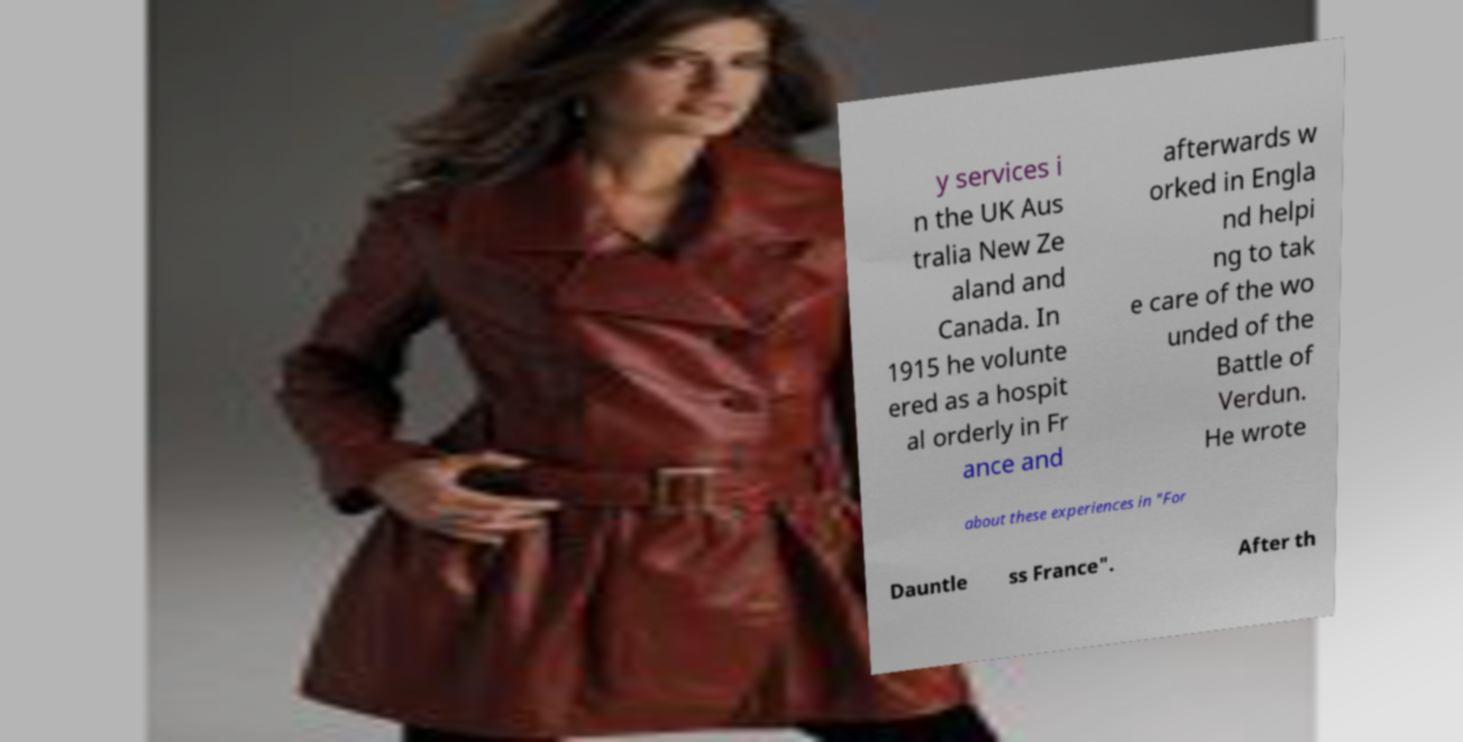Can you read and provide the text displayed in the image?This photo seems to have some interesting text. Can you extract and type it out for me? y services i n the UK Aus tralia New Ze aland and Canada. In 1915 he volunte ered as a hospit al orderly in Fr ance and afterwards w orked in Engla nd helpi ng to tak e care of the wo unded of the Battle of Verdun. He wrote about these experiences in "For Dauntle ss France". After th 